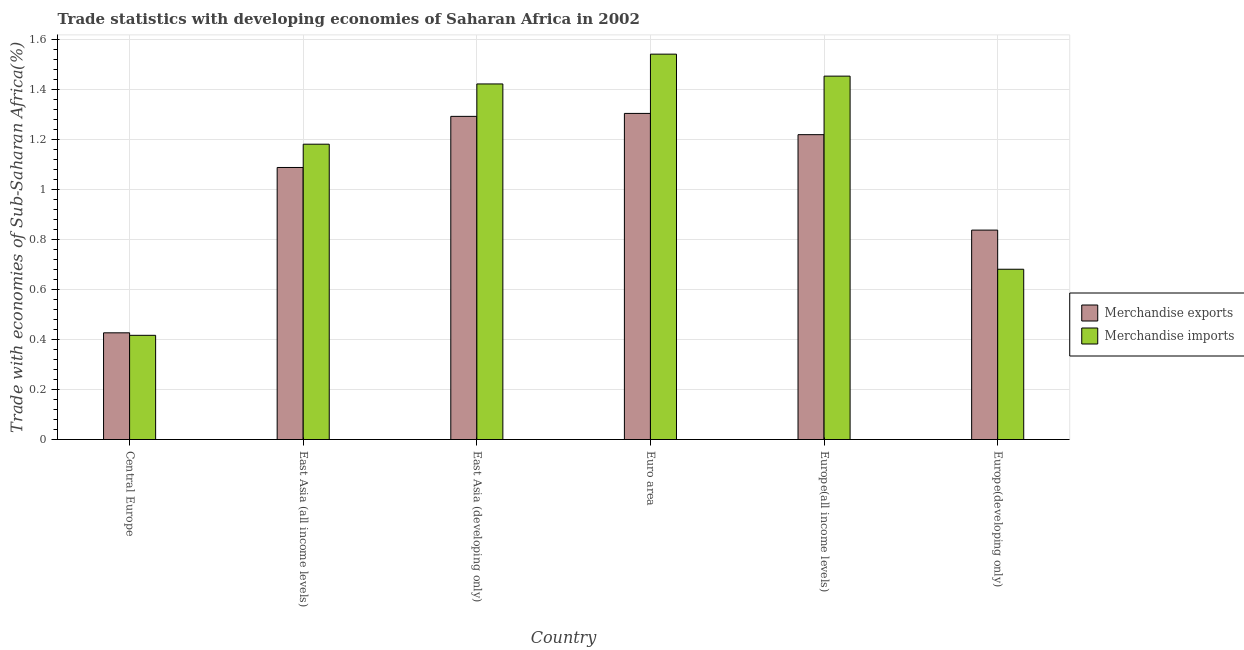How many groups of bars are there?
Your answer should be very brief. 6. Are the number of bars per tick equal to the number of legend labels?
Provide a short and direct response. Yes. What is the label of the 2nd group of bars from the left?
Ensure brevity in your answer.  East Asia (all income levels). In how many cases, is the number of bars for a given country not equal to the number of legend labels?
Your response must be concise. 0. What is the merchandise exports in East Asia (developing only)?
Make the answer very short. 1.29. Across all countries, what is the maximum merchandise imports?
Give a very brief answer. 1.54. Across all countries, what is the minimum merchandise exports?
Your answer should be very brief. 0.43. In which country was the merchandise imports maximum?
Your response must be concise. Euro area. In which country was the merchandise exports minimum?
Ensure brevity in your answer.  Central Europe. What is the total merchandise imports in the graph?
Provide a succinct answer. 6.7. What is the difference between the merchandise imports in East Asia (all income levels) and that in Europe(developing only)?
Your answer should be compact. 0.5. What is the difference between the merchandise exports in Central Europe and the merchandise imports in Europe(developing only)?
Your response must be concise. -0.25. What is the average merchandise exports per country?
Keep it short and to the point. 1.03. What is the difference between the merchandise imports and merchandise exports in Central Europe?
Make the answer very short. -0.01. What is the ratio of the merchandise exports in Euro area to that in Europe(developing only)?
Offer a very short reply. 1.56. Is the merchandise imports in Central Europe less than that in East Asia (all income levels)?
Keep it short and to the point. Yes. Is the difference between the merchandise imports in East Asia (developing only) and Europe(all income levels) greater than the difference between the merchandise exports in East Asia (developing only) and Europe(all income levels)?
Provide a short and direct response. No. What is the difference between the highest and the second highest merchandise exports?
Provide a succinct answer. 0.01. What is the difference between the highest and the lowest merchandise imports?
Your answer should be very brief. 1.13. What does the 2nd bar from the right in East Asia (all income levels) represents?
Your response must be concise. Merchandise exports. How many bars are there?
Offer a terse response. 12. Are all the bars in the graph horizontal?
Ensure brevity in your answer.  No. How many countries are there in the graph?
Offer a very short reply. 6. What is the difference between two consecutive major ticks on the Y-axis?
Provide a succinct answer. 0.2. Does the graph contain grids?
Make the answer very short. Yes. Where does the legend appear in the graph?
Make the answer very short. Center right. What is the title of the graph?
Make the answer very short. Trade statistics with developing economies of Saharan Africa in 2002. What is the label or title of the X-axis?
Give a very brief answer. Country. What is the label or title of the Y-axis?
Your response must be concise. Trade with economies of Sub-Saharan Africa(%). What is the Trade with economies of Sub-Saharan Africa(%) in Merchandise exports in Central Europe?
Offer a very short reply. 0.43. What is the Trade with economies of Sub-Saharan Africa(%) of Merchandise imports in Central Europe?
Your answer should be very brief. 0.42. What is the Trade with economies of Sub-Saharan Africa(%) of Merchandise exports in East Asia (all income levels)?
Offer a terse response. 1.09. What is the Trade with economies of Sub-Saharan Africa(%) in Merchandise imports in East Asia (all income levels)?
Offer a terse response. 1.18. What is the Trade with economies of Sub-Saharan Africa(%) of Merchandise exports in East Asia (developing only)?
Make the answer very short. 1.29. What is the Trade with economies of Sub-Saharan Africa(%) of Merchandise imports in East Asia (developing only)?
Your answer should be compact. 1.42. What is the Trade with economies of Sub-Saharan Africa(%) in Merchandise exports in Euro area?
Make the answer very short. 1.31. What is the Trade with economies of Sub-Saharan Africa(%) of Merchandise imports in Euro area?
Ensure brevity in your answer.  1.54. What is the Trade with economies of Sub-Saharan Africa(%) in Merchandise exports in Europe(all income levels)?
Offer a very short reply. 1.22. What is the Trade with economies of Sub-Saharan Africa(%) in Merchandise imports in Europe(all income levels)?
Your answer should be very brief. 1.45. What is the Trade with economies of Sub-Saharan Africa(%) of Merchandise exports in Europe(developing only)?
Ensure brevity in your answer.  0.84. What is the Trade with economies of Sub-Saharan Africa(%) in Merchandise imports in Europe(developing only)?
Give a very brief answer. 0.68. Across all countries, what is the maximum Trade with economies of Sub-Saharan Africa(%) of Merchandise exports?
Ensure brevity in your answer.  1.31. Across all countries, what is the maximum Trade with economies of Sub-Saharan Africa(%) of Merchandise imports?
Keep it short and to the point. 1.54. Across all countries, what is the minimum Trade with economies of Sub-Saharan Africa(%) in Merchandise exports?
Offer a very short reply. 0.43. Across all countries, what is the minimum Trade with economies of Sub-Saharan Africa(%) of Merchandise imports?
Offer a very short reply. 0.42. What is the total Trade with economies of Sub-Saharan Africa(%) in Merchandise exports in the graph?
Give a very brief answer. 6.17. What is the total Trade with economies of Sub-Saharan Africa(%) of Merchandise imports in the graph?
Your answer should be compact. 6.7. What is the difference between the Trade with economies of Sub-Saharan Africa(%) of Merchandise exports in Central Europe and that in East Asia (all income levels)?
Make the answer very short. -0.66. What is the difference between the Trade with economies of Sub-Saharan Africa(%) of Merchandise imports in Central Europe and that in East Asia (all income levels)?
Provide a succinct answer. -0.76. What is the difference between the Trade with economies of Sub-Saharan Africa(%) of Merchandise exports in Central Europe and that in East Asia (developing only)?
Ensure brevity in your answer.  -0.87. What is the difference between the Trade with economies of Sub-Saharan Africa(%) of Merchandise imports in Central Europe and that in East Asia (developing only)?
Provide a short and direct response. -1.01. What is the difference between the Trade with economies of Sub-Saharan Africa(%) in Merchandise exports in Central Europe and that in Euro area?
Ensure brevity in your answer.  -0.88. What is the difference between the Trade with economies of Sub-Saharan Africa(%) of Merchandise imports in Central Europe and that in Euro area?
Ensure brevity in your answer.  -1.13. What is the difference between the Trade with economies of Sub-Saharan Africa(%) in Merchandise exports in Central Europe and that in Europe(all income levels)?
Your response must be concise. -0.79. What is the difference between the Trade with economies of Sub-Saharan Africa(%) of Merchandise imports in Central Europe and that in Europe(all income levels)?
Your response must be concise. -1.04. What is the difference between the Trade with economies of Sub-Saharan Africa(%) of Merchandise exports in Central Europe and that in Europe(developing only)?
Your answer should be compact. -0.41. What is the difference between the Trade with economies of Sub-Saharan Africa(%) of Merchandise imports in Central Europe and that in Europe(developing only)?
Your answer should be very brief. -0.26. What is the difference between the Trade with economies of Sub-Saharan Africa(%) in Merchandise exports in East Asia (all income levels) and that in East Asia (developing only)?
Your response must be concise. -0.2. What is the difference between the Trade with economies of Sub-Saharan Africa(%) of Merchandise imports in East Asia (all income levels) and that in East Asia (developing only)?
Provide a succinct answer. -0.24. What is the difference between the Trade with economies of Sub-Saharan Africa(%) in Merchandise exports in East Asia (all income levels) and that in Euro area?
Provide a succinct answer. -0.22. What is the difference between the Trade with economies of Sub-Saharan Africa(%) of Merchandise imports in East Asia (all income levels) and that in Euro area?
Your answer should be compact. -0.36. What is the difference between the Trade with economies of Sub-Saharan Africa(%) of Merchandise exports in East Asia (all income levels) and that in Europe(all income levels)?
Ensure brevity in your answer.  -0.13. What is the difference between the Trade with economies of Sub-Saharan Africa(%) of Merchandise imports in East Asia (all income levels) and that in Europe(all income levels)?
Provide a succinct answer. -0.27. What is the difference between the Trade with economies of Sub-Saharan Africa(%) of Merchandise exports in East Asia (all income levels) and that in Europe(developing only)?
Offer a terse response. 0.25. What is the difference between the Trade with economies of Sub-Saharan Africa(%) of Merchandise imports in East Asia (all income levels) and that in Europe(developing only)?
Offer a terse response. 0.5. What is the difference between the Trade with economies of Sub-Saharan Africa(%) in Merchandise exports in East Asia (developing only) and that in Euro area?
Keep it short and to the point. -0.01. What is the difference between the Trade with economies of Sub-Saharan Africa(%) in Merchandise imports in East Asia (developing only) and that in Euro area?
Offer a very short reply. -0.12. What is the difference between the Trade with economies of Sub-Saharan Africa(%) in Merchandise exports in East Asia (developing only) and that in Europe(all income levels)?
Offer a very short reply. 0.07. What is the difference between the Trade with economies of Sub-Saharan Africa(%) of Merchandise imports in East Asia (developing only) and that in Europe(all income levels)?
Provide a short and direct response. -0.03. What is the difference between the Trade with economies of Sub-Saharan Africa(%) of Merchandise exports in East Asia (developing only) and that in Europe(developing only)?
Provide a succinct answer. 0.46. What is the difference between the Trade with economies of Sub-Saharan Africa(%) in Merchandise imports in East Asia (developing only) and that in Europe(developing only)?
Keep it short and to the point. 0.74. What is the difference between the Trade with economies of Sub-Saharan Africa(%) in Merchandise exports in Euro area and that in Europe(all income levels)?
Provide a short and direct response. 0.09. What is the difference between the Trade with economies of Sub-Saharan Africa(%) of Merchandise imports in Euro area and that in Europe(all income levels)?
Provide a short and direct response. 0.09. What is the difference between the Trade with economies of Sub-Saharan Africa(%) of Merchandise exports in Euro area and that in Europe(developing only)?
Your answer should be very brief. 0.47. What is the difference between the Trade with economies of Sub-Saharan Africa(%) in Merchandise imports in Euro area and that in Europe(developing only)?
Your answer should be compact. 0.86. What is the difference between the Trade with economies of Sub-Saharan Africa(%) in Merchandise exports in Europe(all income levels) and that in Europe(developing only)?
Make the answer very short. 0.38. What is the difference between the Trade with economies of Sub-Saharan Africa(%) of Merchandise imports in Europe(all income levels) and that in Europe(developing only)?
Your answer should be compact. 0.77. What is the difference between the Trade with economies of Sub-Saharan Africa(%) in Merchandise exports in Central Europe and the Trade with economies of Sub-Saharan Africa(%) in Merchandise imports in East Asia (all income levels)?
Make the answer very short. -0.75. What is the difference between the Trade with economies of Sub-Saharan Africa(%) in Merchandise exports in Central Europe and the Trade with economies of Sub-Saharan Africa(%) in Merchandise imports in East Asia (developing only)?
Make the answer very short. -1. What is the difference between the Trade with economies of Sub-Saharan Africa(%) in Merchandise exports in Central Europe and the Trade with economies of Sub-Saharan Africa(%) in Merchandise imports in Euro area?
Your answer should be compact. -1.12. What is the difference between the Trade with economies of Sub-Saharan Africa(%) of Merchandise exports in Central Europe and the Trade with economies of Sub-Saharan Africa(%) of Merchandise imports in Europe(all income levels)?
Ensure brevity in your answer.  -1.03. What is the difference between the Trade with economies of Sub-Saharan Africa(%) of Merchandise exports in Central Europe and the Trade with economies of Sub-Saharan Africa(%) of Merchandise imports in Europe(developing only)?
Your response must be concise. -0.25. What is the difference between the Trade with economies of Sub-Saharan Africa(%) of Merchandise exports in East Asia (all income levels) and the Trade with economies of Sub-Saharan Africa(%) of Merchandise imports in East Asia (developing only)?
Provide a short and direct response. -0.33. What is the difference between the Trade with economies of Sub-Saharan Africa(%) in Merchandise exports in East Asia (all income levels) and the Trade with economies of Sub-Saharan Africa(%) in Merchandise imports in Euro area?
Your answer should be compact. -0.45. What is the difference between the Trade with economies of Sub-Saharan Africa(%) in Merchandise exports in East Asia (all income levels) and the Trade with economies of Sub-Saharan Africa(%) in Merchandise imports in Europe(all income levels)?
Provide a succinct answer. -0.37. What is the difference between the Trade with economies of Sub-Saharan Africa(%) of Merchandise exports in East Asia (all income levels) and the Trade with economies of Sub-Saharan Africa(%) of Merchandise imports in Europe(developing only)?
Ensure brevity in your answer.  0.41. What is the difference between the Trade with economies of Sub-Saharan Africa(%) in Merchandise exports in East Asia (developing only) and the Trade with economies of Sub-Saharan Africa(%) in Merchandise imports in Euro area?
Offer a very short reply. -0.25. What is the difference between the Trade with economies of Sub-Saharan Africa(%) of Merchandise exports in East Asia (developing only) and the Trade with economies of Sub-Saharan Africa(%) of Merchandise imports in Europe(all income levels)?
Your answer should be compact. -0.16. What is the difference between the Trade with economies of Sub-Saharan Africa(%) in Merchandise exports in East Asia (developing only) and the Trade with economies of Sub-Saharan Africa(%) in Merchandise imports in Europe(developing only)?
Offer a very short reply. 0.61. What is the difference between the Trade with economies of Sub-Saharan Africa(%) in Merchandise exports in Euro area and the Trade with economies of Sub-Saharan Africa(%) in Merchandise imports in Europe(all income levels)?
Provide a short and direct response. -0.15. What is the difference between the Trade with economies of Sub-Saharan Africa(%) in Merchandise exports in Euro area and the Trade with economies of Sub-Saharan Africa(%) in Merchandise imports in Europe(developing only)?
Your answer should be very brief. 0.62. What is the difference between the Trade with economies of Sub-Saharan Africa(%) in Merchandise exports in Europe(all income levels) and the Trade with economies of Sub-Saharan Africa(%) in Merchandise imports in Europe(developing only)?
Offer a terse response. 0.54. What is the average Trade with economies of Sub-Saharan Africa(%) of Merchandise exports per country?
Offer a terse response. 1.03. What is the average Trade with economies of Sub-Saharan Africa(%) in Merchandise imports per country?
Provide a succinct answer. 1.12. What is the difference between the Trade with economies of Sub-Saharan Africa(%) in Merchandise exports and Trade with economies of Sub-Saharan Africa(%) in Merchandise imports in East Asia (all income levels)?
Offer a very short reply. -0.09. What is the difference between the Trade with economies of Sub-Saharan Africa(%) of Merchandise exports and Trade with economies of Sub-Saharan Africa(%) of Merchandise imports in East Asia (developing only)?
Ensure brevity in your answer.  -0.13. What is the difference between the Trade with economies of Sub-Saharan Africa(%) in Merchandise exports and Trade with economies of Sub-Saharan Africa(%) in Merchandise imports in Euro area?
Offer a very short reply. -0.24. What is the difference between the Trade with economies of Sub-Saharan Africa(%) in Merchandise exports and Trade with economies of Sub-Saharan Africa(%) in Merchandise imports in Europe(all income levels)?
Offer a terse response. -0.23. What is the difference between the Trade with economies of Sub-Saharan Africa(%) of Merchandise exports and Trade with economies of Sub-Saharan Africa(%) of Merchandise imports in Europe(developing only)?
Give a very brief answer. 0.16. What is the ratio of the Trade with economies of Sub-Saharan Africa(%) in Merchandise exports in Central Europe to that in East Asia (all income levels)?
Your response must be concise. 0.39. What is the ratio of the Trade with economies of Sub-Saharan Africa(%) in Merchandise imports in Central Europe to that in East Asia (all income levels)?
Give a very brief answer. 0.35. What is the ratio of the Trade with economies of Sub-Saharan Africa(%) in Merchandise exports in Central Europe to that in East Asia (developing only)?
Your answer should be compact. 0.33. What is the ratio of the Trade with economies of Sub-Saharan Africa(%) of Merchandise imports in Central Europe to that in East Asia (developing only)?
Provide a short and direct response. 0.29. What is the ratio of the Trade with economies of Sub-Saharan Africa(%) in Merchandise exports in Central Europe to that in Euro area?
Make the answer very short. 0.33. What is the ratio of the Trade with economies of Sub-Saharan Africa(%) in Merchandise imports in Central Europe to that in Euro area?
Provide a short and direct response. 0.27. What is the ratio of the Trade with economies of Sub-Saharan Africa(%) in Merchandise exports in Central Europe to that in Europe(all income levels)?
Your response must be concise. 0.35. What is the ratio of the Trade with economies of Sub-Saharan Africa(%) in Merchandise imports in Central Europe to that in Europe(all income levels)?
Offer a very short reply. 0.29. What is the ratio of the Trade with economies of Sub-Saharan Africa(%) of Merchandise exports in Central Europe to that in Europe(developing only)?
Keep it short and to the point. 0.51. What is the ratio of the Trade with economies of Sub-Saharan Africa(%) of Merchandise imports in Central Europe to that in Europe(developing only)?
Give a very brief answer. 0.61. What is the ratio of the Trade with economies of Sub-Saharan Africa(%) of Merchandise exports in East Asia (all income levels) to that in East Asia (developing only)?
Make the answer very short. 0.84. What is the ratio of the Trade with economies of Sub-Saharan Africa(%) of Merchandise imports in East Asia (all income levels) to that in East Asia (developing only)?
Keep it short and to the point. 0.83. What is the ratio of the Trade with economies of Sub-Saharan Africa(%) of Merchandise exports in East Asia (all income levels) to that in Euro area?
Ensure brevity in your answer.  0.83. What is the ratio of the Trade with economies of Sub-Saharan Africa(%) of Merchandise imports in East Asia (all income levels) to that in Euro area?
Make the answer very short. 0.77. What is the ratio of the Trade with economies of Sub-Saharan Africa(%) in Merchandise exports in East Asia (all income levels) to that in Europe(all income levels)?
Provide a short and direct response. 0.89. What is the ratio of the Trade with economies of Sub-Saharan Africa(%) in Merchandise imports in East Asia (all income levels) to that in Europe(all income levels)?
Your response must be concise. 0.81. What is the ratio of the Trade with economies of Sub-Saharan Africa(%) of Merchandise exports in East Asia (all income levels) to that in Europe(developing only)?
Ensure brevity in your answer.  1.3. What is the ratio of the Trade with economies of Sub-Saharan Africa(%) of Merchandise imports in East Asia (all income levels) to that in Europe(developing only)?
Give a very brief answer. 1.73. What is the ratio of the Trade with economies of Sub-Saharan Africa(%) in Merchandise imports in East Asia (developing only) to that in Euro area?
Provide a succinct answer. 0.92. What is the ratio of the Trade with economies of Sub-Saharan Africa(%) of Merchandise exports in East Asia (developing only) to that in Europe(all income levels)?
Provide a short and direct response. 1.06. What is the ratio of the Trade with economies of Sub-Saharan Africa(%) in Merchandise imports in East Asia (developing only) to that in Europe(all income levels)?
Your answer should be compact. 0.98. What is the ratio of the Trade with economies of Sub-Saharan Africa(%) of Merchandise exports in East Asia (developing only) to that in Europe(developing only)?
Your answer should be compact. 1.54. What is the ratio of the Trade with economies of Sub-Saharan Africa(%) in Merchandise imports in East Asia (developing only) to that in Europe(developing only)?
Make the answer very short. 2.09. What is the ratio of the Trade with economies of Sub-Saharan Africa(%) in Merchandise exports in Euro area to that in Europe(all income levels)?
Offer a very short reply. 1.07. What is the ratio of the Trade with economies of Sub-Saharan Africa(%) of Merchandise imports in Euro area to that in Europe(all income levels)?
Your answer should be very brief. 1.06. What is the ratio of the Trade with economies of Sub-Saharan Africa(%) of Merchandise exports in Euro area to that in Europe(developing only)?
Your answer should be compact. 1.56. What is the ratio of the Trade with economies of Sub-Saharan Africa(%) in Merchandise imports in Euro area to that in Europe(developing only)?
Keep it short and to the point. 2.26. What is the ratio of the Trade with economies of Sub-Saharan Africa(%) of Merchandise exports in Europe(all income levels) to that in Europe(developing only)?
Provide a short and direct response. 1.46. What is the ratio of the Trade with economies of Sub-Saharan Africa(%) of Merchandise imports in Europe(all income levels) to that in Europe(developing only)?
Keep it short and to the point. 2.13. What is the difference between the highest and the second highest Trade with economies of Sub-Saharan Africa(%) in Merchandise exports?
Offer a very short reply. 0.01. What is the difference between the highest and the second highest Trade with economies of Sub-Saharan Africa(%) of Merchandise imports?
Offer a terse response. 0.09. What is the difference between the highest and the lowest Trade with economies of Sub-Saharan Africa(%) of Merchandise exports?
Provide a short and direct response. 0.88. What is the difference between the highest and the lowest Trade with economies of Sub-Saharan Africa(%) in Merchandise imports?
Your answer should be very brief. 1.13. 